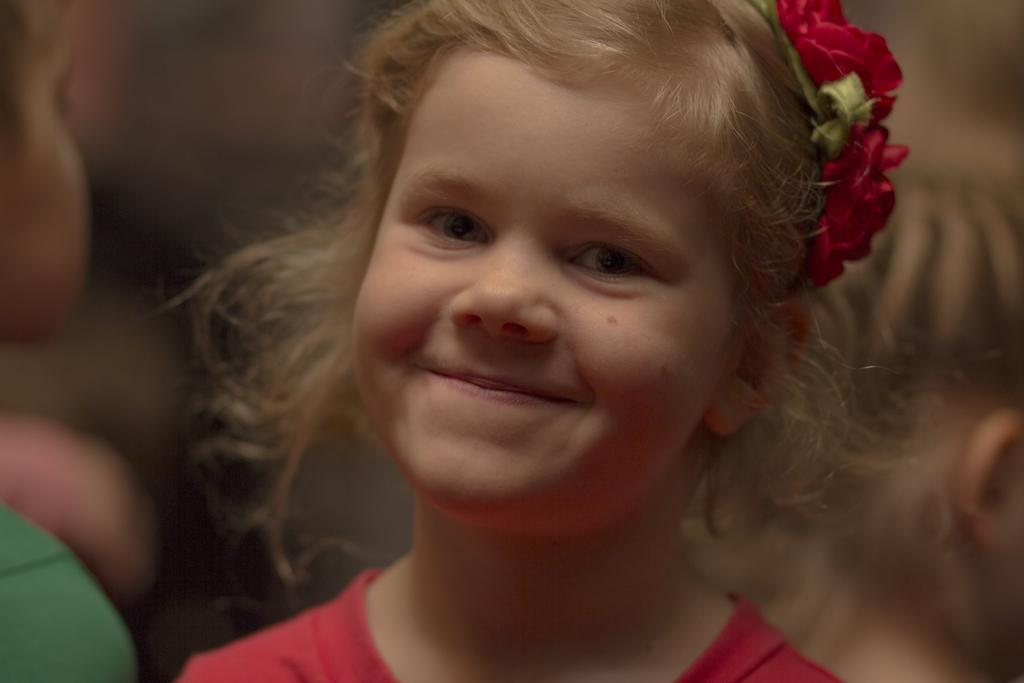Who is the main subject in the image? There is a girl in the image. What is the girl's expression in the image? The girl is smiling in the image. Can you describe the background of the image? The background of the image is blurred. How many forks can be seen in the image? A: There are no forks present in the image. What type of guide is the girl holding in the image? There is no guide present in the image. 